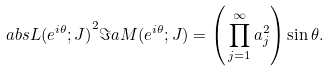<formula> <loc_0><loc_0><loc_500><loc_500>\ a b s { L ( e ^ { i \theta } ; J ) } ^ { 2 } \Im a M ( e ^ { i \theta } ; J ) = \left ( \, \prod _ { j = 1 } ^ { \infty } a _ { j } ^ { 2 } \right ) \sin \theta .</formula> 